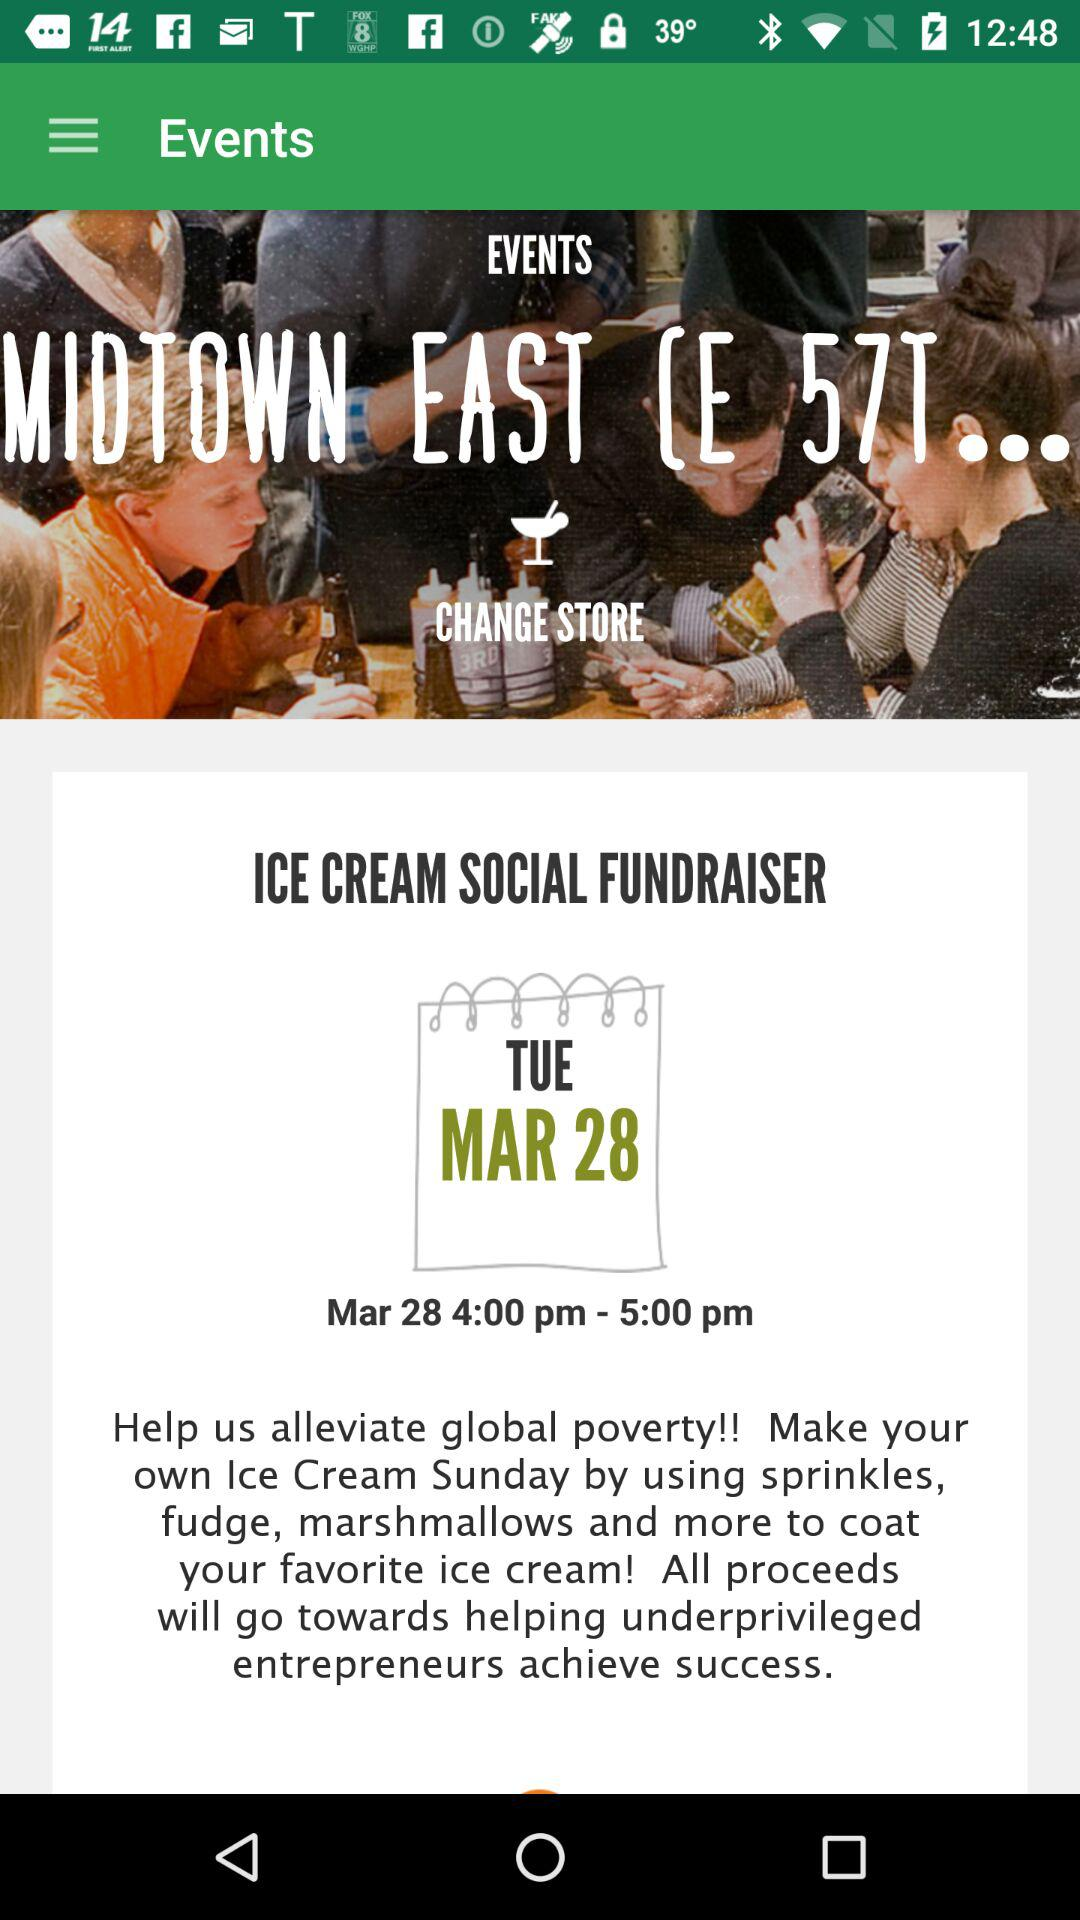In which year does the event take place?
When the provided information is insufficient, respond with <no answer>. <no answer> 